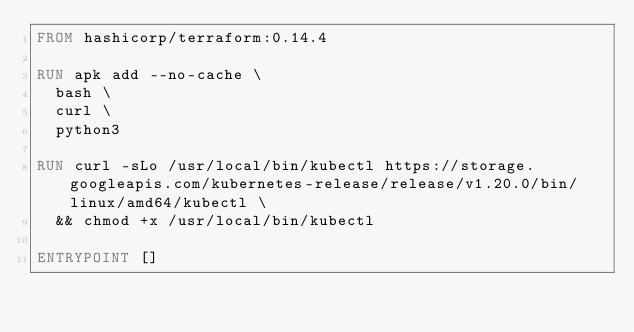Convert code to text. <code><loc_0><loc_0><loc_500><loc_500><_Dockerfile_>FROM hashicorp/terraform:0.14.4

RUN apk add --no-cache \
  bash \
  curl \
  python3

RUN curl -sLo /usr/local/bin/kubectl https://storage.googleapis.com/kubernetes-release/release/v1.20.0/bin/linux/amd64/kubectl \
  && chmod +x /usr/local/bin/kubectl

ENTRYPOINT []
</code> 